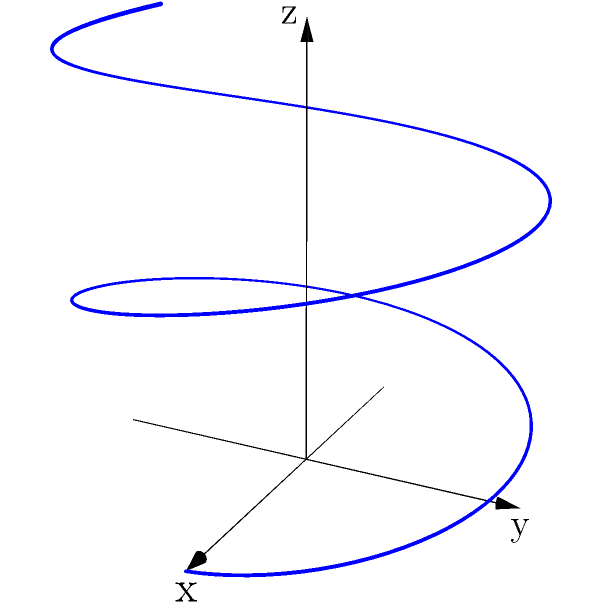Given the 3D curve representing a simplified protein folding topology, which topological property is most likely to be conserved during the folding process? To answer this question, let's analyze the topological properties of the given 3D curve:

1. The curve appears to be a helix, which is a common secondary structure in proteins (alpha-helix).

2. Topological properties that could be considered:
   a) Handedness (chirality)
   b) Number of turns
   c) Pitch (distance between turns)
   d) Radius

3. Among these properties, handedness is the most likely to be conserved during protein folding:
   a) Handedness is determined by the amino acid sequence and is intrinsic to the protein's primary structure.
   b) It is typically preserved during the folding process due to the fixed chirality of amino acids.
   c) Other properties like the number of turns, pitch, and radius can be more easily affected by environmental factors or mutations.

4. In protein folding:
   a) The overall 3D structure (tertiary structure) may change significantly.
   b) Secondary structures like alpha-helices often maintain their handedness.
   c) This conservation of handedness is crucial for maintaining the protein's function.

5. For a chemist validating natural medicinal compounds:
   a) Understanding conserved topological properties is essential for predicting how compounds might interact with proteins.
   b) Handedness can affect a compound's ability to bind to specific protein sites.

Therefore, the topological property most likely to be conserved during the protein folding process represented by this 3D curve is its handedness or chirality.
Answer: Handedness (chirality) 